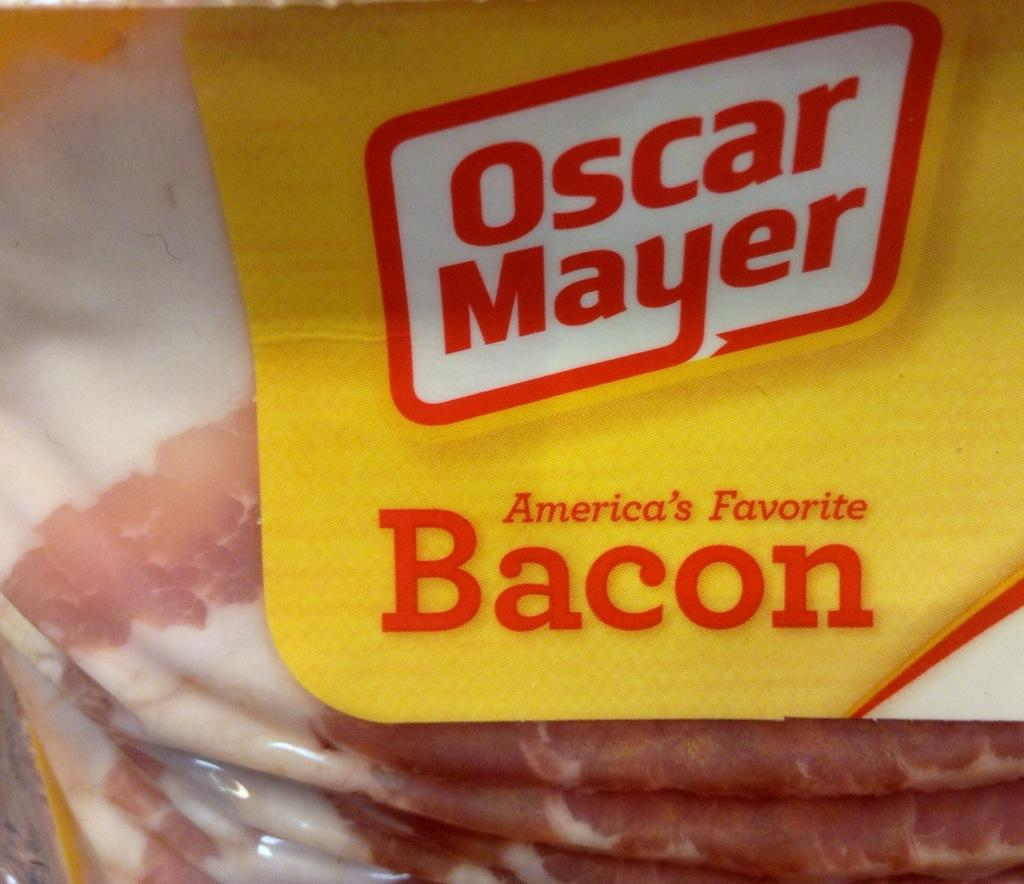What type of food items are in the packet in the image? There are meat items in a packet in the image. Can you describe the possible setting where the image might have been taken? The image may have been taken in a shop. What grade did the meat items receive in the image? There is no indication of a grade for the meat items in the image. How does the image say good-bye to the meat items? The image does not depict any action or message related to saying good-bye to the meat items. 